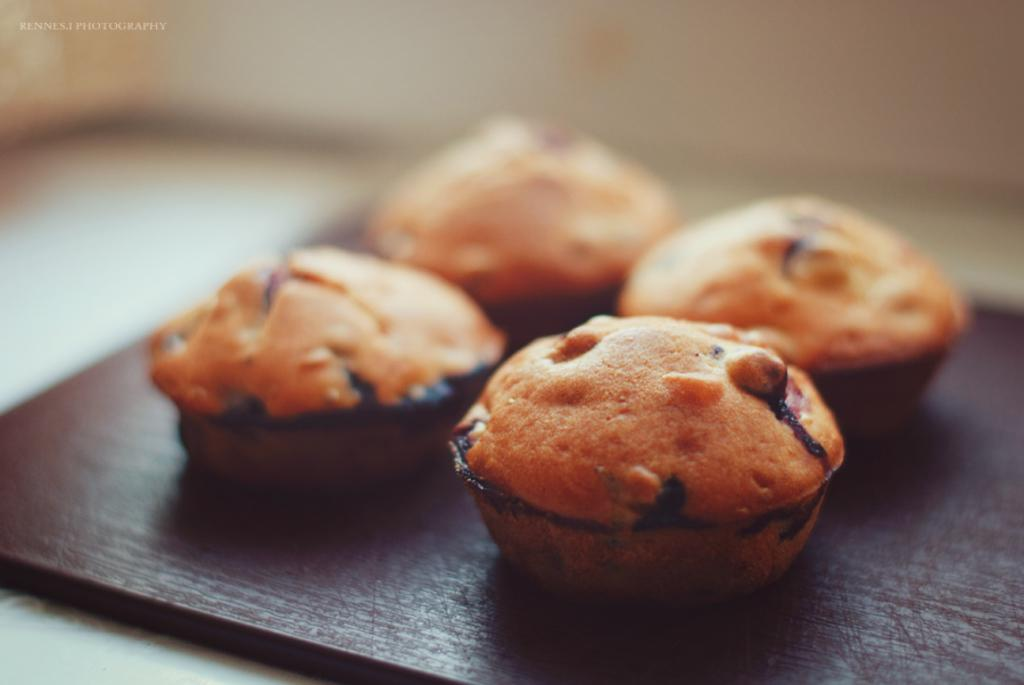What color are the cupcakes in the image? The cupcakes in the image are brown. What is the surface on which the cupcakes are placed? The cupcakes are on a brown color surface. Can you describe the background of the image? The background of the image is blurred. Can you see a bee buzzing around the cupcakes in the image? There is no bee present in the image. Is there a road visible in the background of the image? There is no road visible in the image; the background is blurred. 